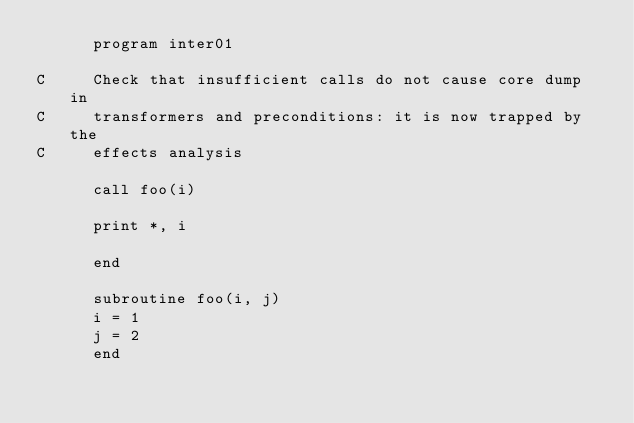<code> <loc_0><loc_0><loc_500><loc_500><_FORTRAN_>      program inter01

C     Check that insufficient calls do not cause core dump in
C     transformers and preconditions: it is now trapped by the
C     effects analysis

      call foo(i)

      print *, i

      end

      subroutine foo(i, j)
      i = 1
      j = 2
      end
</code> 